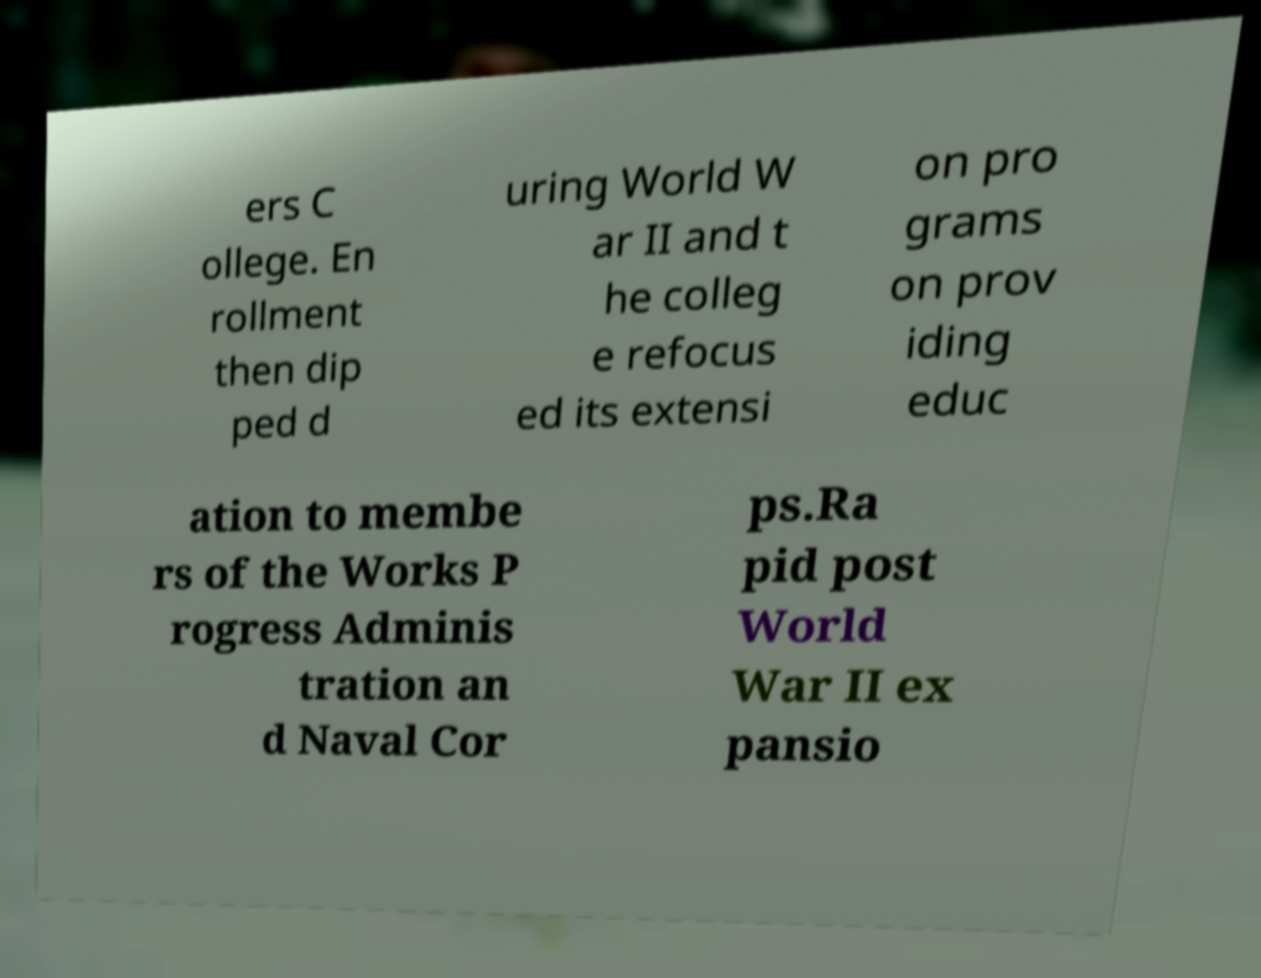Please read and relay the text visible in this image. What does it say? ers C ollege. En rollment then dip ped d uring World W ar II and t he colleg e refocus ed its extensi on pro grams on prov iding educ ation to membe rs of the Works P rogress Adminis tration an d Naval Cor ps.Ra pid post World War II ex pansio 